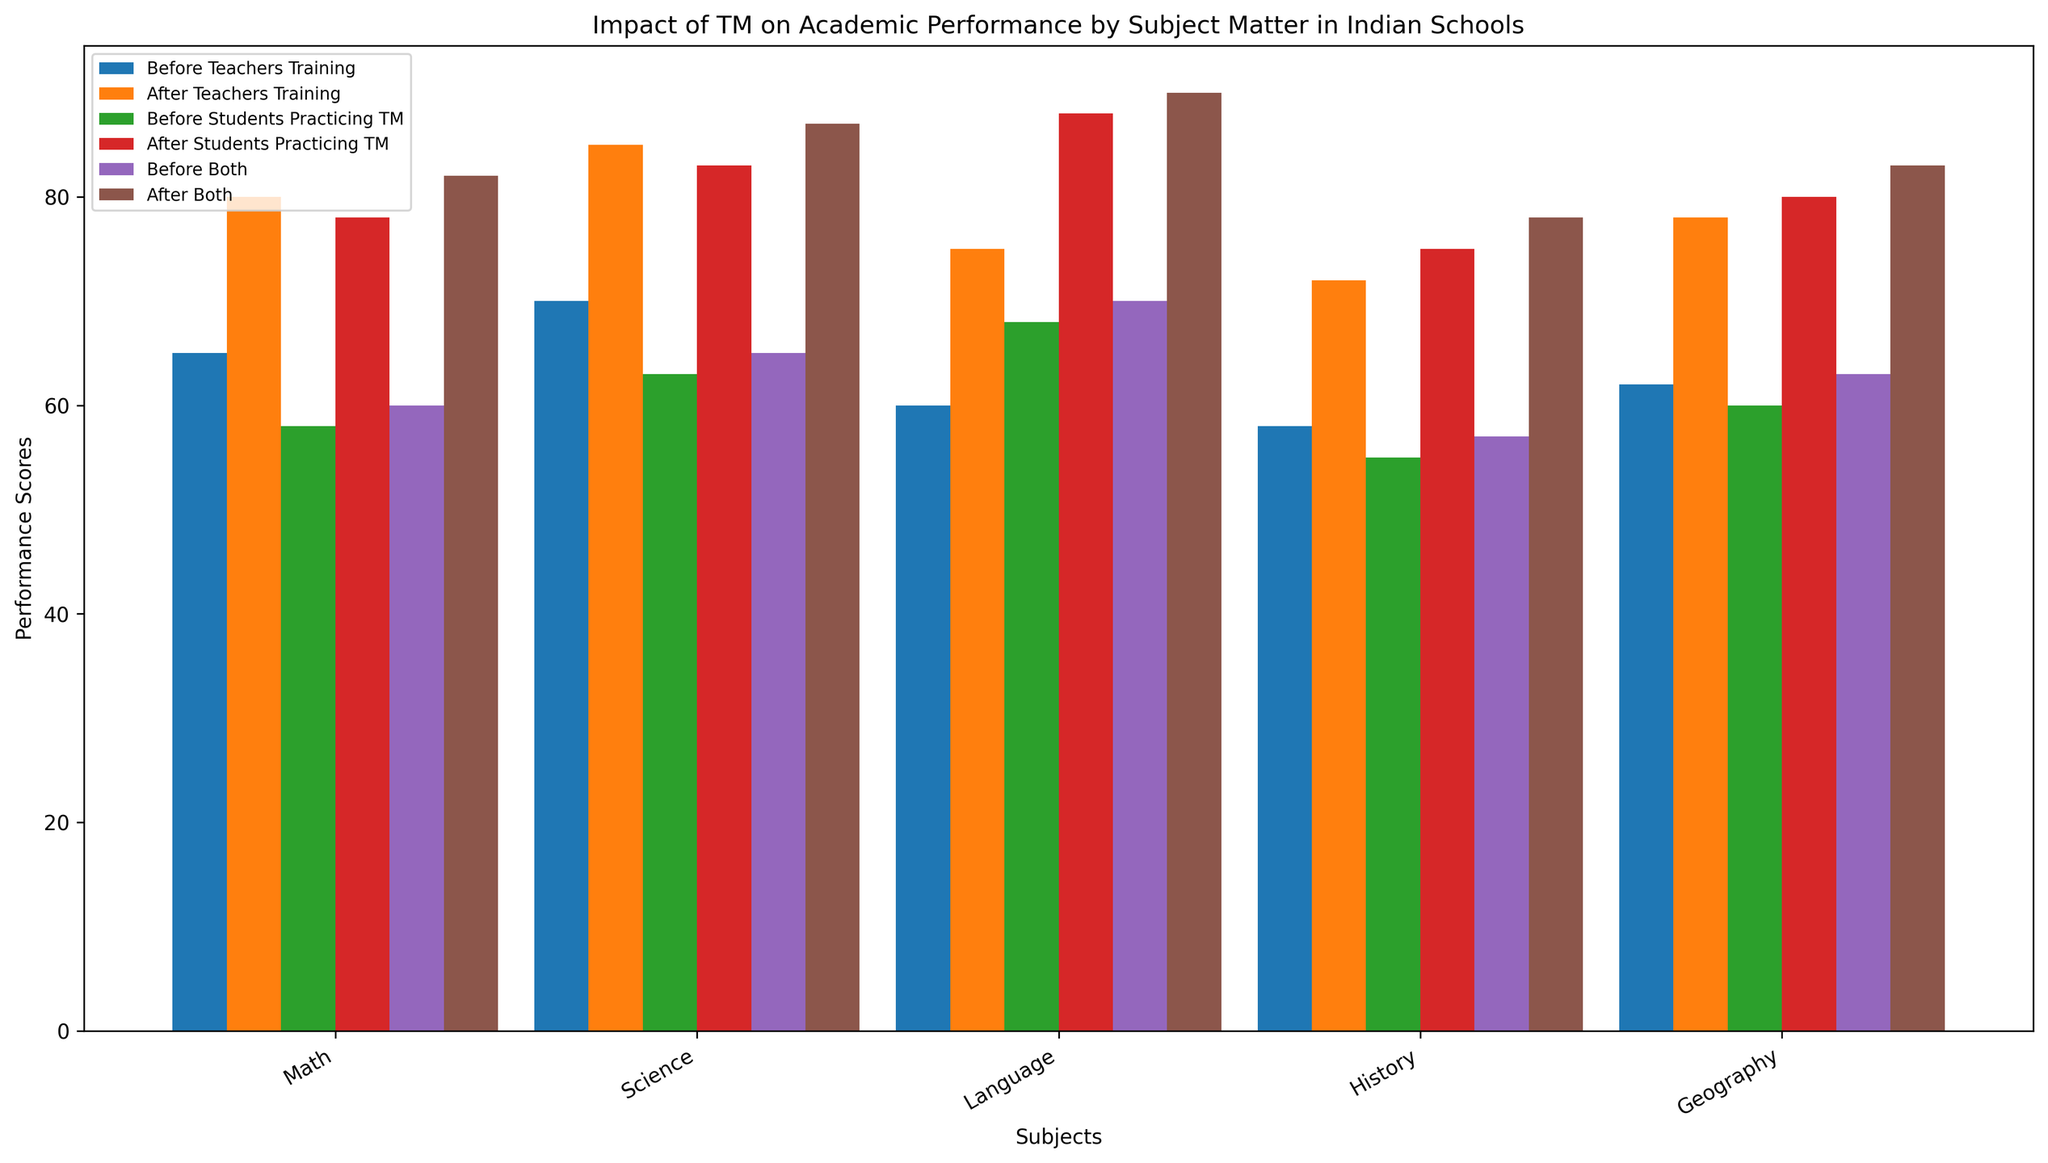What is the increase in academic performance in Math after teachers' training? To find the increase, subtract the 'Before Teachers Training' score from the 'After Teachers Training' score for Math. So, 80 - 65 = 15
Answer: 15 Compare the performance in Science before and after both TM practices combined. Look at the bars for 'Before Both' and 'After Both' in Science. 'Before Both' shows 65 and 'After Both' shows 87. Compare these values directly.
Answer: 'After Both' is 22 points higher Which subject has the highest increase in performance after students start practicing TM? Calculate the increase for each subject by subtracting 'Before Students Practicing TM' from 'After Students Practicing TM' for each subject. Math: 78 - 58 = 20, Science: 83 - 63 = 20, Language: 88 - 68 = 20, History: 75 - 55 = 20, Geography: 80 - 60 = 20. All increases are the same, so all subjects have the highest increase.
Answer: All subjects By how much does the performance in Language improve when both teachers are trained and students practice TM? Subtract the 'Before Both' score from the 'After Both' score for Language. 90 - 70 = 20
Answer: 20 In which subject does teachers' training alone have the least impact on performance? Calculate the improvement for each subject by subtracting 'Before Teachers Training' from 'After Teachers Training'. Math: 80 - 65 = 15, Science: 85 - 70 = 15, Language: 75 - 60 = 15, History: 72 - 58 = 14, Geography: 78 - 62 = 16. History has the smallest increase.
Answer: History What is the combined average performance score of Geography before and after students practice TM? Calculate the average by adding the 'Before Students Practicing TM' and 'After Students Practicing TM' scores for Geography, then divide by 2. (60 + 80) / 2 = 70
Answer: 70 Which intervention - teachers' training, students practicing TM, or both - shows the highest improvement in academic performance across all subjects? Calculate the total improvement for each intervention by summing the scores across all subjects and comparing. 
Teachers' training: (80-65) + (85-70) + (75-60) + (72-58) + (78-62) = 75
Students practicing TM: (78-58) + (83-63) + (88-68) + (75-55) + (80-60) = 90
Both: (82-60) + (87-65) + (90-70) + (78-57) + (83-63) = 105
'Both' shows the highest improvement.
Answer: Both Does the performance increase more for students in History or Geography after practicing TM compared to before? Compare the increase for History and Geography after students practice TM. History: 75 - 55 = 20, Geography: 80 - 60 = 20. The increases are equal.
Answer: Equal 